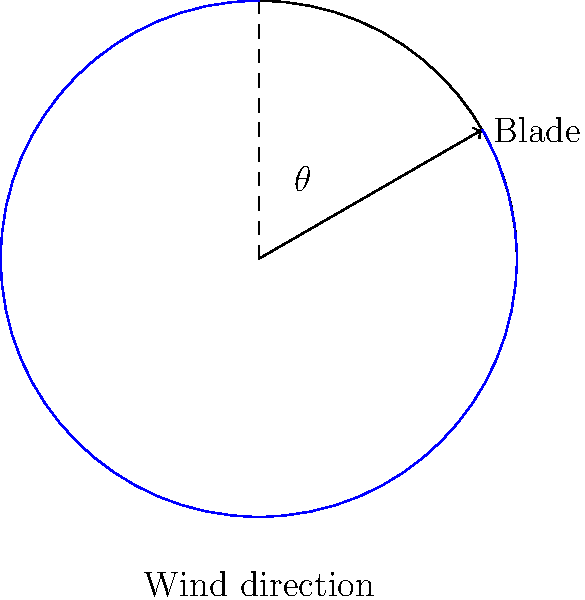In a wind turbine design project, you're studying the optimal angle for blade positioning. The diagram shows a wind turbine blade at an angle $\theta$ from the vertical. If the most efficient angle for capturing wind energy is when the blade is perpendicular to the wind direction, what should the angle $\theta$ be? Let's approach this step-by-step:

1) First, we need to understand what "perpendicular to the wind direction" means. In the diagram, the wind direction is shown as horizontal (from left to right).

2) For a blade to be perpendicular to the wind direction, it needs to form a 90° angle with the wind's path.

3) In the diagram, we see that the angle $\theta$ is measured from the vertical position of the blade.

4) If we imagine rotating the blade from its vertical position to be perpendicular to the wind:
   - It would need to rotate by 90° from the vertical.
   - This rotation would make it horizontal, and thus perpendicular to the wind direction.

5) Therefore, the angle $\theta$ should be equal to 90°.

This 90° angle ensures that the blade presents the maximum surface area to the wind, allowing it to capture the most wind energy efficiently.
Answer: $90°$ 